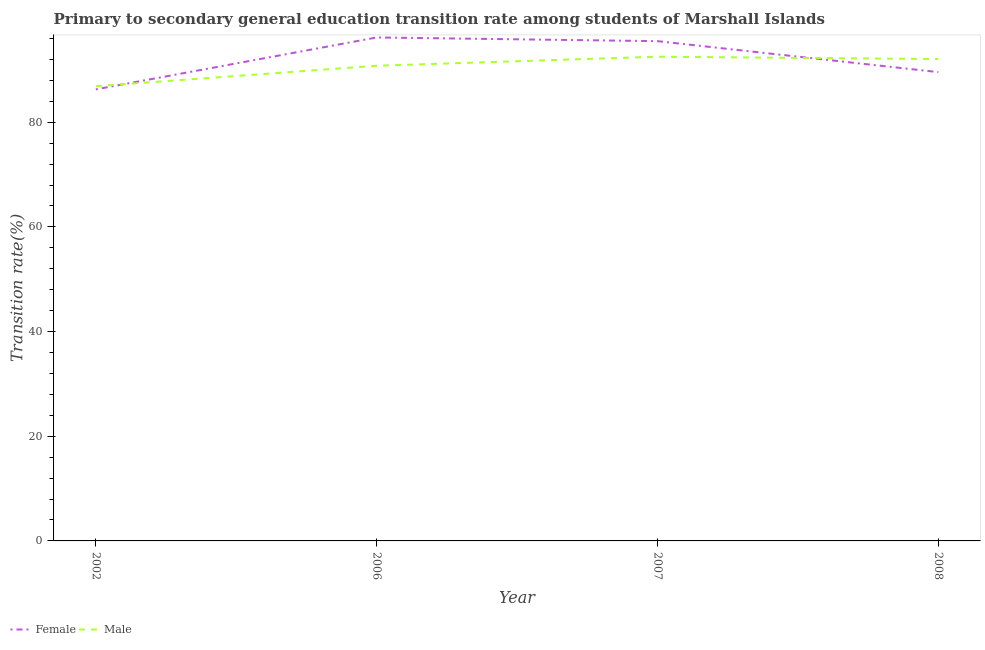How many different coloured lines are there?
Make the answer very short. 2. Does the line corresponding to transition rate among male students intersect with the line corresponding to transition rate among female students?
Your response must be concise. Yes. What is the transition rate among female students in 2002?
Provide a short and direct response. 86.27. Across all years, what is the maximum transition rate among male students?
Provide a short and direct response. 92.51. Across all years, what is the minimum transition rate among female students?
Your response must be concise. 86.27. In which year was the transition rate among female students maximum?
Make the answer very short. 2006. In which year was the transition rate among male students minimum?
Your answer should be very brief. 2002. What is the total transition rate among male students in the graph?
Your answer should be compact. 362.24. What is the difference between the transition rate among male students in 2006 and that in 2007?
Offer a terse response. -1.73. What is the difference between the transition rate among male students in 2002 and the transition rate among female students in 2007?
Your answer should be compact. -8.61. What is the average transition rate among male students per year?
Your answer should be very brief. 90.56. In the year 2002, what is the difference between the transition rate among male students and transition rate among female students?
Provide a short and direct response. 0.6. What is the ratio of the transition rate among male students in 2002 to that in 2007?
Provide a short and direct response. 0.94. Is the difference between the transition rate among female students in 2002 and 2008 greater than the difference between the transition rate among male students in 2002 and 2008?
Provide a short and direct response. Yes. What is the difference between the highest and the second highest transition rate among female students?
Make the answer very short. 0.7. What is the difference between the highest and the lowest transition rate among female students?
Provide a succinct answer. 9.91. Does the transition rate among female students monotonically increase over the years?
Make the answer very short. No. Is the transition rate among female students strictly less than the transition rate among male students over the years?
Provide a short and direct response. No. How many lines are there?
Provide a short and direct response. 2. Does the graph contain grids?
Keep it short and to the point. No. How are the legend labels stacked?
Offer a very short reply. Horizontal. What is the title of the graph?
Your answer should be very brief. Primary to secondary general education transition rate among students of Marshall Islands. What is the label or title of the Y-axis?
Give a very brief answer. Transition rate(%). What is the Transition rate(%) of Female in 2002?
Your response must be concise. 86.27. What is the Transition rate(%) in Male in 2002?
Keep it short and to the point. 86.88. What is the Transition rate(%) of Female in 2006?
Make the answer very short. 96.19. What is the Transition rate(%) in Male in 2006?
Your answer should be compact. 90.78. What is the Transition rate(%) of Female in 2007?
Give a very brief answer. 95.48. What is the Transition rate(%) in Male in 2007?
Offer a very short reply. 92.51. What is the Transition rate(%) of Female in 2008?
Provide a short and direct response. 89.57. What is the Transition rate(%) in Male in 2008?
Offer a terse response. 92.06. Across all years, what is the maximum Transition rate(%) in Female?
Offer a terse response. 96.19. Across all years, what is the maximum Transition rate(%) in Male?
Make the answer very short. 92.51. Across all years, what is the minimum Transition rate(%) in Female?
Your response must be concise. 86.27. Across all years, what is the minimum Transition rate(%) of Male?
Your answer should be very brief. 86.88. What is the total Transition rate(%) in Female in the graph?
Make the answer very short. 367.51. What is the total Transition rate(%) of Male in the graph?
Make the answer very short. 362.24. What is the difference between the Transition rate(%) in Female in 2002 and that in 2006?
Provide a short and direct response. -9.91. What is the difference between the Transition rate(%) in Male in 2002 and that in 2006?
Offer a very short reply. -3.91. What is the difference between the Transition rate(%) in Female in 2002 and that in 2007?
Your answer should be compact. -9.21. What is the difference between the Transition rate(%) in Male in 2002 and that in 2007?
Make the answer very short. -5.64. What is the difference between the Transition rate(%) in Female in 2002 and that in 2008?
Ensure brevity in your answer.  -3.29. What is the difference between the Transition rate(%) in Male in 2002 and that in 2008?
Your answer should be very brief. -5.19. What is the difference between the Transition rate(%) of Female in 2006 and that in 2007?
Provide a succinct answer. 0.7. What is the difference between the Transition rate(%) in Male in 2006 and that in 2007?
Offer a terse response. -1.73. What is the difference between the Transition rate(%) in Female in 2006 and that in 2008?
Provide a succinct answer. 6.62. What is the difference between the Transition rate(%) of Male in 2006 and that in 2008?
Offer a very short reply. -1.28. What is the difference between the Transition rate(%) in Female in 2007 and that in 2008?
Provide a short and direct response. 5.92. What is the difference between the Transition rate(%) in Male in 2007 and that in 2008?
Keep it short and to the point. 0.45. What is the difference between the Transition rate(%) in Female in 2002 and the Transition rate(%) in Male in 2006?
Provide a short and direct response. -4.51. What is the difference between the Transition rate(%) in Female in 2002 and the Transition rate(%) in Male in 2007?
Offer a terse response. -6.24. What is the difference between the Transition rate(%) of Female in 2002 and the Transition rate(%) of Male in 2008?
Offer a terse response. -5.79. What is the difference between the Transition rate(%) of Female in 2006 and the Transition rate(%) of Male in 2007?
Provide a succinct answer. 3.67. What is the difference between the Transition rate(%) of Female in 2006 and the Transition rate(%) of Male in 2008?
Ensure brevity in your answer.  4.12. What is the difference between the Transition rate(%) in Female in 2007 and the Transition rate(%) in Male in 2008?
Make the answer very short. 3.42. What is the average Transition rate(%) of Female per year?
Your answer should be very brief. 91.88. What is the average Transition rate(%) of Male per year?
Keep it short and to the point. 90.56. In the year 2002, what is the difference between the Transition rate(%) of Female and Transition rate(%) of Male?
Give a very brief answer. -0.6. In the year 2006, what is the difference between the Transition rate(%) in Female and Transition rate(%) in Male?
Give a very brief answer. 5.4. In the year 2007, what is the difference between the Transition rate(%) of Female and Transition rate(%) of Male?
Give a very brief answer. 2.97. In the year 2008, what is the difference between the Transition rate(%) of Female and Transition rate(%) of Male?
Offer a terse response. -2.5. What is the ratio of the Transition rate(%) in Female in 2002 to that in 2006?
Give a very brief answer. 0.9. What is the ratio of the Transition rate(%) of Male in 2002 to that in 2006?
Offer a terse response. 0.96. What is the ratio of the Transition rate(%) in Female in 2002 to that in 2007?
Offer a terse response. 0.9. What is the ratio of the Transition rate(%) of Male in 2002 to that in 2007?
Ensure brevity in your answer.  0.94. What is the ratio of the Transition rate(%) in Female in 2002 to that in 2008?
Give a very brief answer. 0.96. What is the ratio of the Transition rate(%) in Male in 2002 to that in 2008?
Provide a succinct answer. 0.94. What is the ratio of the Transition rate(%) in Female in 2006 to that in 2007?
Give a very brief answer. 1.01. What is the ratio of the Transition rate(%) of Male in 2006 to that in 2007?
Offer a terse response. 0.98. What is the ratio of the Transition rate(%) of Female in 2006 to that in 2008?
Your answer should be compact. 1.07. What is the ratio of the Transition rate(%) in Male in 2006 to that in 2008?
Make the answer very short. 0.99. What is the ratio of the Transition rate(%) of Female in 2007 to that in 2008?
Make the answer very short. 1.07. What is the ratio of the Transition rate(%) of Male in 2007 to that in 2008?
Give a very brief answer. 1. What is the difference between the highest and the second highest Transition rate(%) in Female?
Provide a short and direct response. 0.7. What is the difference between the highest and the second highest Transition rate(%) of Male?
Your answer should be very brief. 0.45. What is the difference between the highest and the lowest Transition rate(%) in Female?
Offer a terse response. 9.91. What is the difference between the highest and the lowest Transition rate(%) in Male?
Your answer should be very brief. 5.64. 